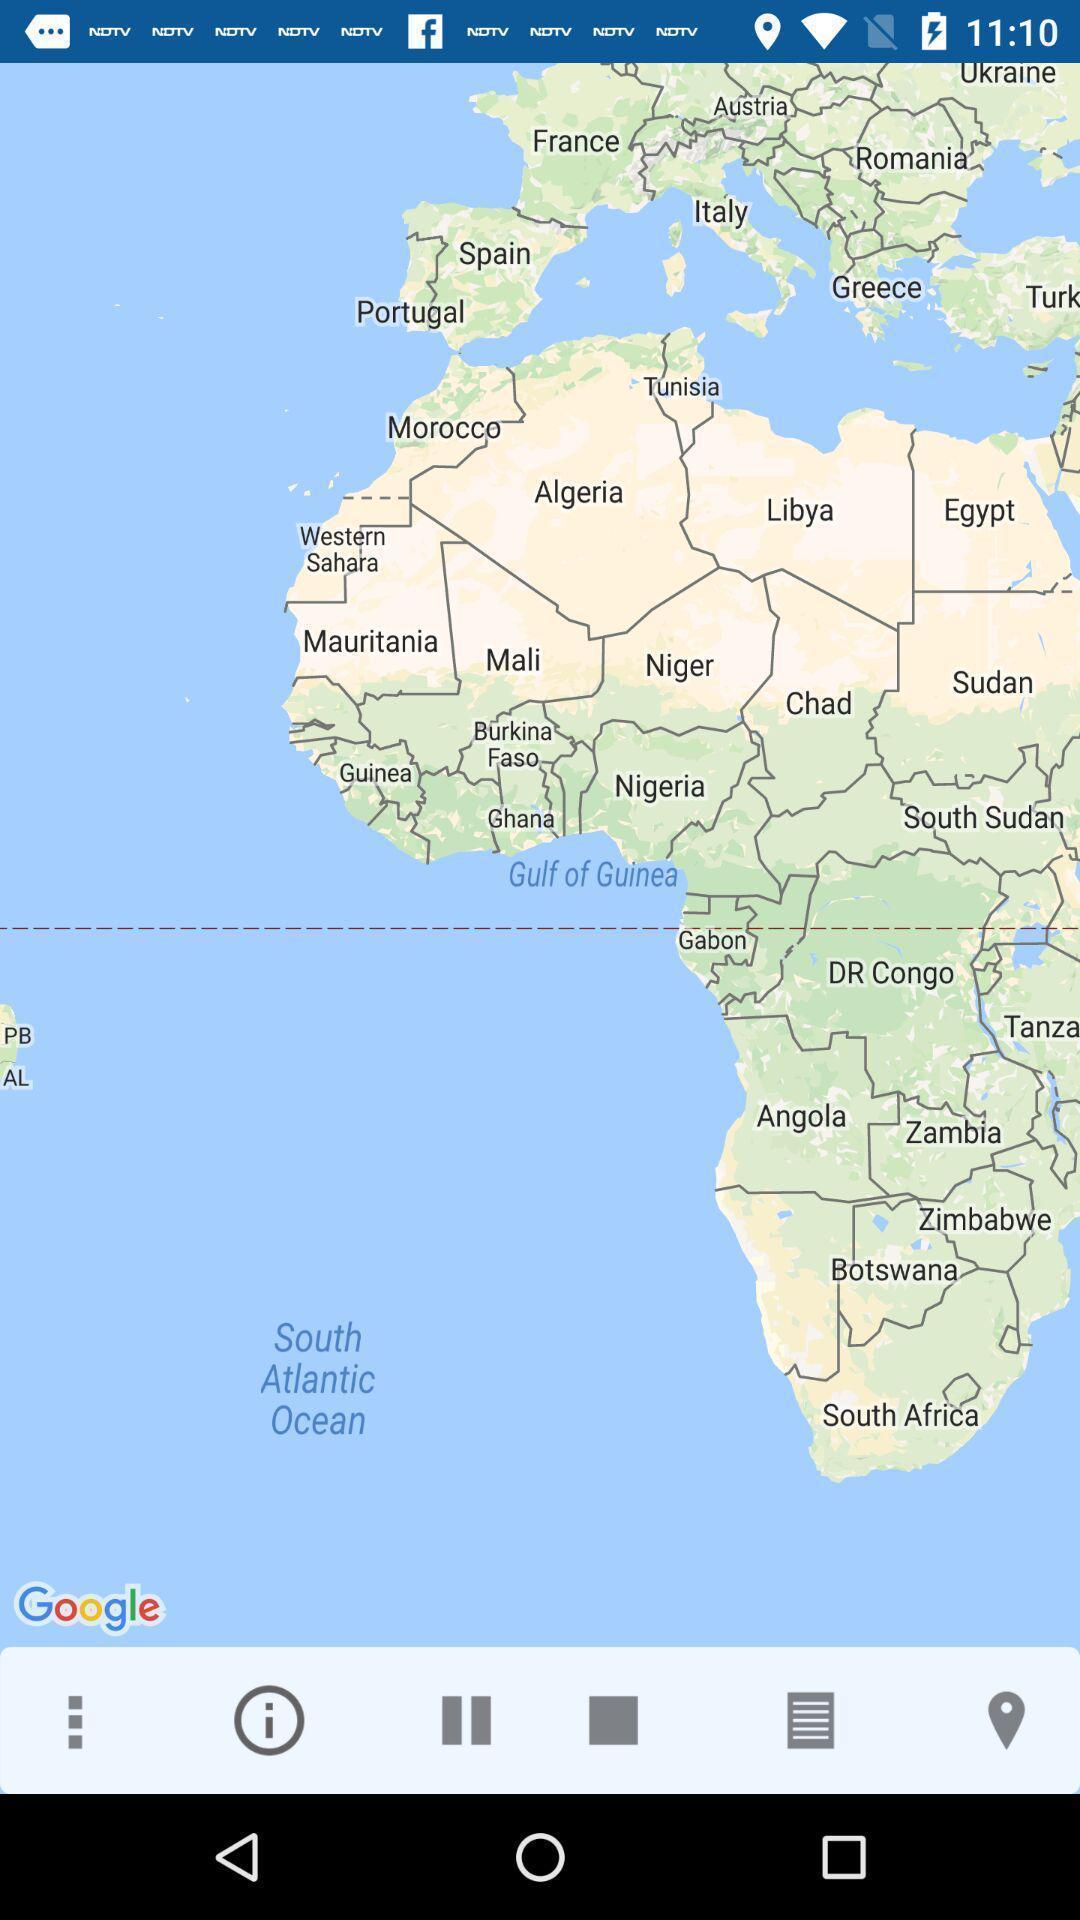Provide a textual representation of this image. Page displaying map in a route tracking app. 